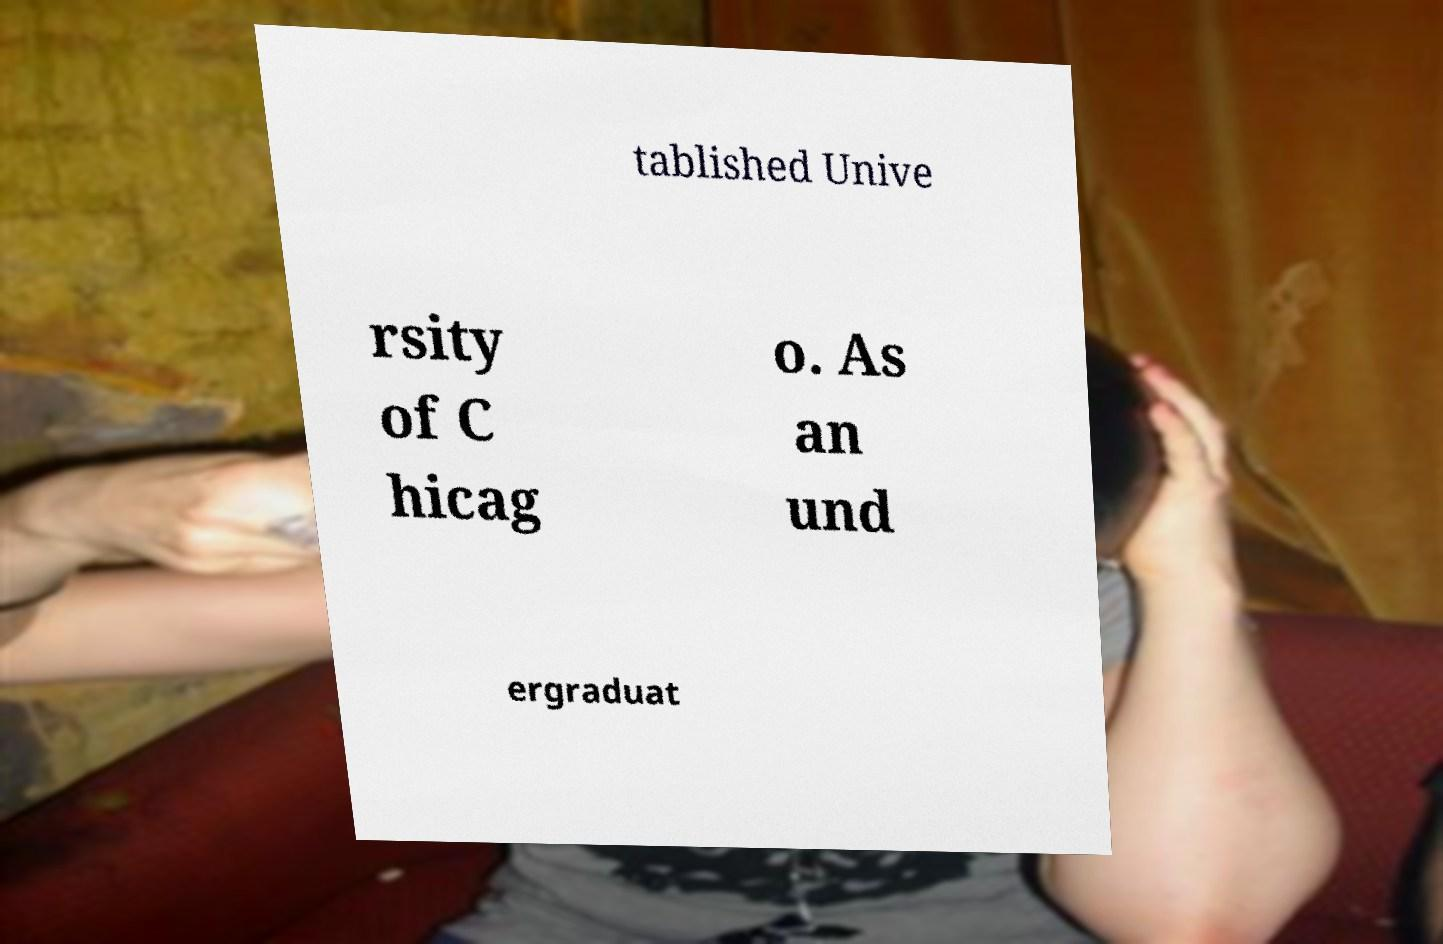What messages or text are displayed in this image? I need them in a readable, typed format. tablished Unive rsity of C hicag o. As an und ergraduat 